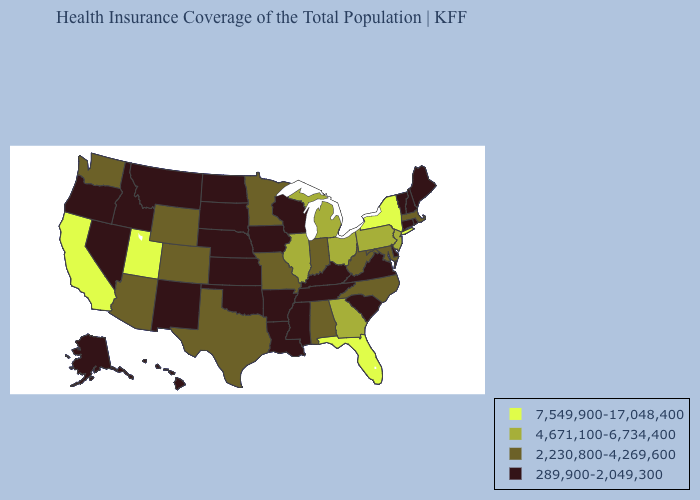What is the value of Nebraska?
Give a very brief answer. 289,900-2,049,300. Does Wyoming have a lower value than Pennsylvania?
Concise answer only. Yes. Name the states that have a value in the range 4,671,100-6,734,400?
Answer briefly. Georgia, Illinois, Michigan, New Jersey, Ohio, Pennsylvania. Does California have the highest value in the USA?
Be succinct. Yes. What is the value of Oregon?
Keep it brief. 289,900-2,049,300. What is the highest value in the MidWest ?
Concise answer only. 4,671,100-6,734,400. What is the value of New Hampshire?
Be succinct. 289,900-2,049,300. Which states have the lowest value in the MidWest?
Answer briefly. Iowa, Kansas, Nebraska, North Dakota, South Dakota, Wisconsin. Does South Carolina have the highest value in the USA?
Answer briefly. No. Which states have the lowest value in the Northeast?
Answer briefly. Connecticut, Maine, New Hampshire, Rhode Island, Vermont. What is the value of Nevada?
Short answer required. 289,900-2,049,300. Name the states that have a value in the range 7,549,900-17,048,400?
Keep it brief. California, Florida, New York, Utah. What is the value of Indiana?
Short answer required. 2,230,800-4,269,600. Does New Jersey have the same value as Vermont?
Answer briefly. No. Name the states that have a value in the range 2,230,800-4,269,600?
Concise answer only. Alabama, Arizona, Colorado, Indiana, Maryland, Massachusetts, Minnesota, Missouri, North Carolina, Texas, Washington, West Virginia, Wyoming. 